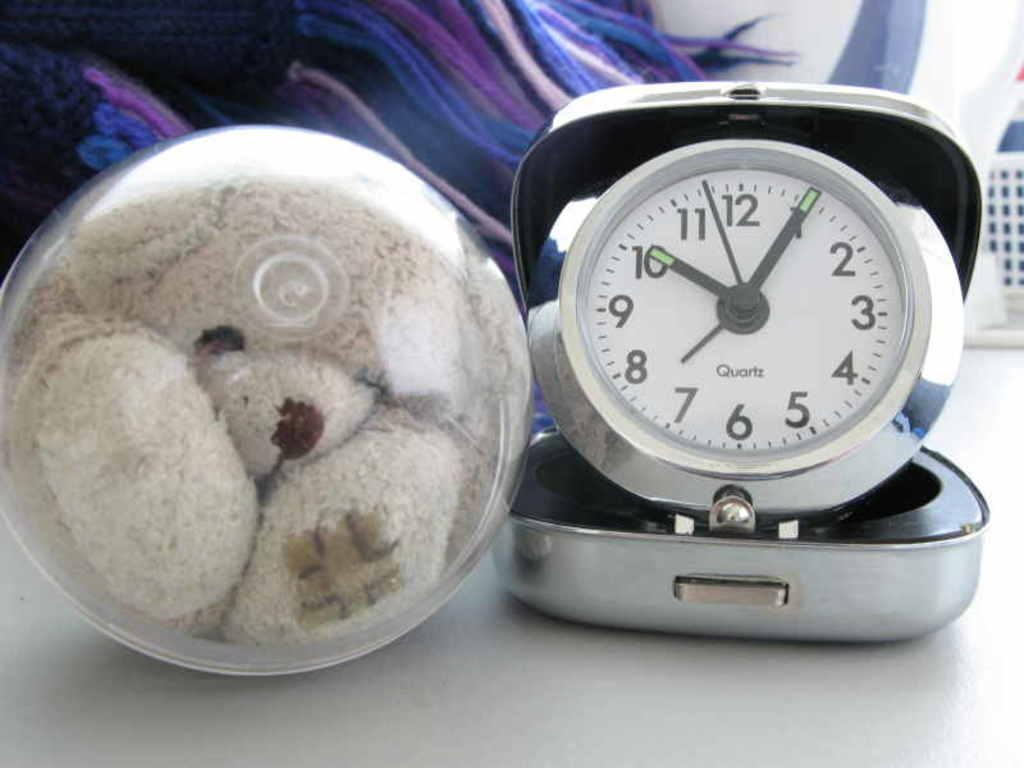Provide a one-sentence caption for the provided image. Teddybear next to a clock from Quartz brand. 